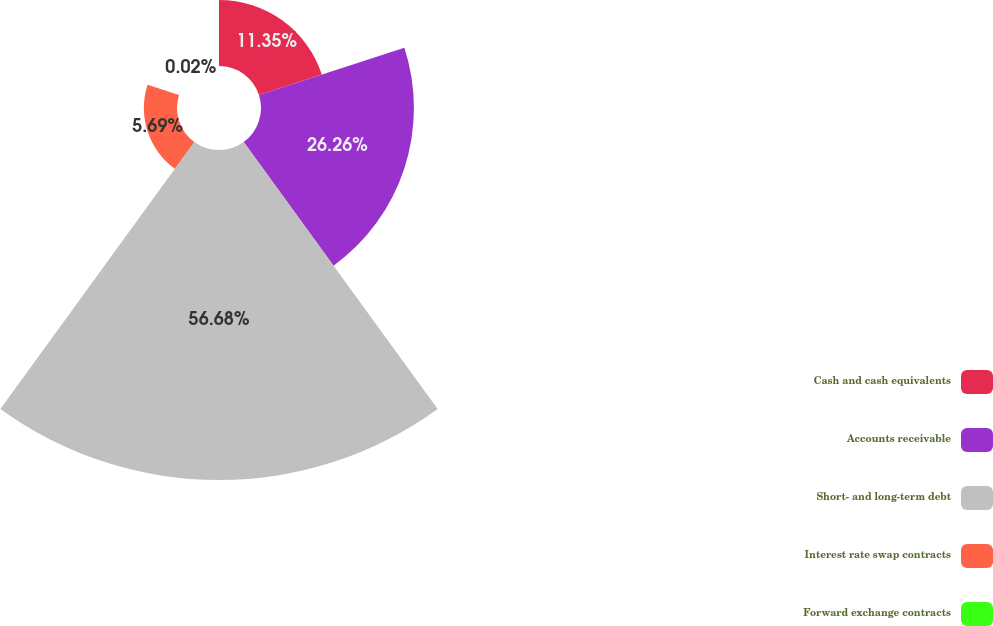<chart> <loc_0><loc_0><loc_500><loc_500><pie_chart><fcel>Cash and cash equivalents<fcel>Accounts receivable<fcel>Short- and long-term debt<fcel>Interest rate swap contracts<fcel>Forward exchange contracts<nl><fcel>11.35%<fcel>26.26%<fcel>56.67%<fcel>5.69%<fcel>0.02%<nl></chart> 